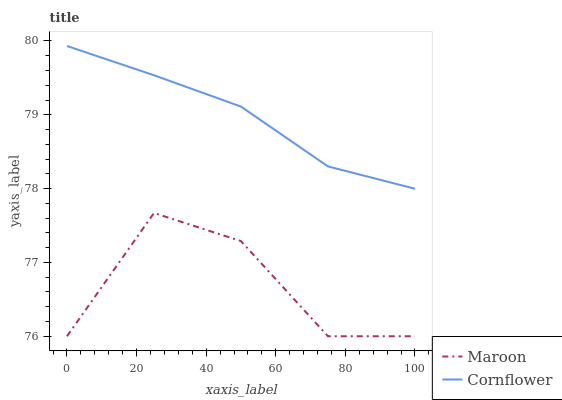Does Maroon have the minimum area under the curve?
Answer yes or no. Yes. Does Cornflower have the maximum area under the curve?
Answer yes or no. Yes. Does Maroon have the maximum area under the curve?
Answer yes or no. No. Is Cornflower the smoothest?
Answer yes or no. Yes. Is Maroon the roughest?
Answer yes or no. Yes. Is Maroon the smoothest?
Answer yes or no. No. Does Maroon have the lowest value?
Answer yes or no. Yes. Does Cornflower have the highest value?
Answer yes or no. Yes. Does Maroon have the highest value?
Answer yes or no. No. Is Maroon less than Cornflower?
Answer yes or no. Yes. Is Cornflower greater than Maroon?
Answer yes or no. Yes. Does Maroon intersect Cornflower?
Answer yes or no. No. 